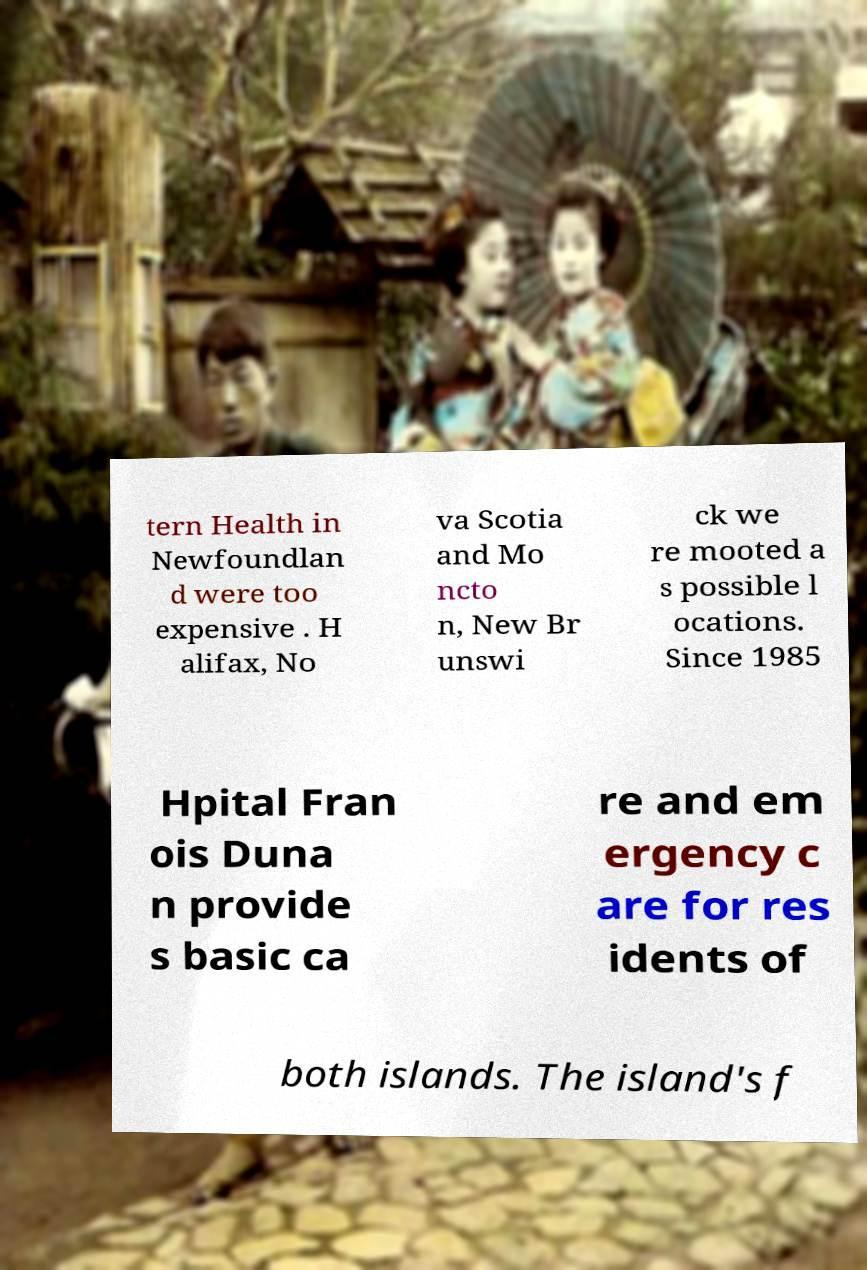Can you read and provide the text displayed in the image?This photo seems to have some interesting text. Can you extract and type it out for me? tern Health in Newfoundlan d were too expensive . H alifax, No va Scotia and Mo ncto n, New Br unswi ck we re mooted a s possible l ocations. Since 1985 Hpital Fran ois Duna n provide s basic ca re and em ergency c are for res idents of both islands. The island's f 